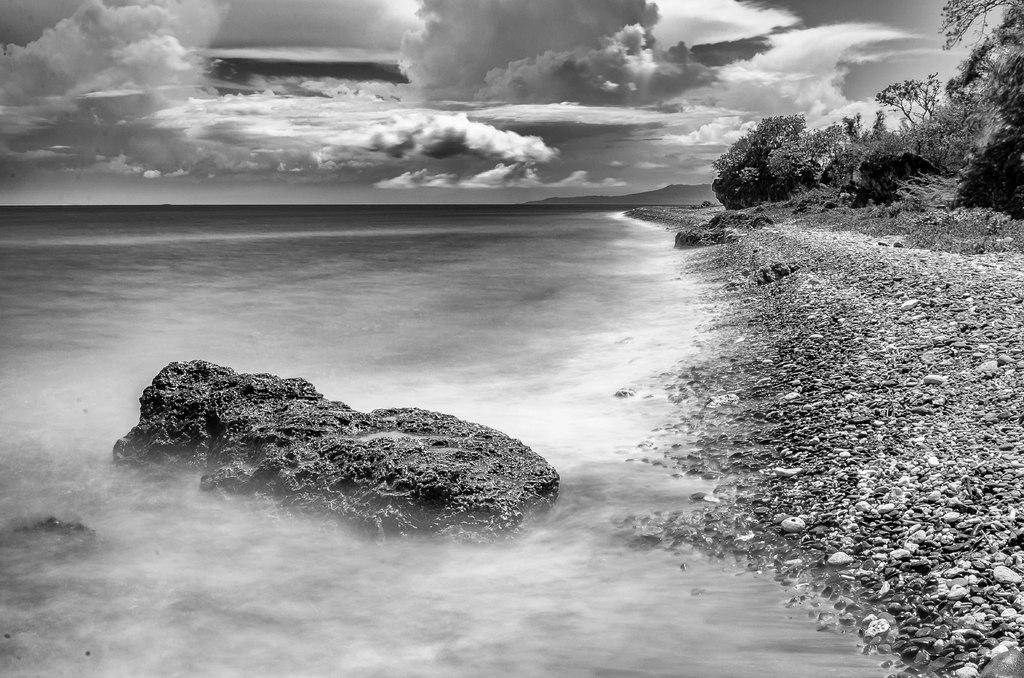What is the primary element visible in the image? There is water in the image. What other objects or features can be seen in the image? There are stones, trees, and clouds visible in the image. What is the color scheme of the image? The image is in black and white. What type of curtain can be seen hanging from the trees in the image? There are no curtains present in the image; it features water, stones, trees, and clouds in a black and white color scheme. 